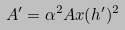<formula> <loc_0><loc_0><loc_500><loc_500>A ^ { \prime } = \alpha ^ { 2 } A x ( h ^ { \prime } ) ^ { 2 }</formula> 